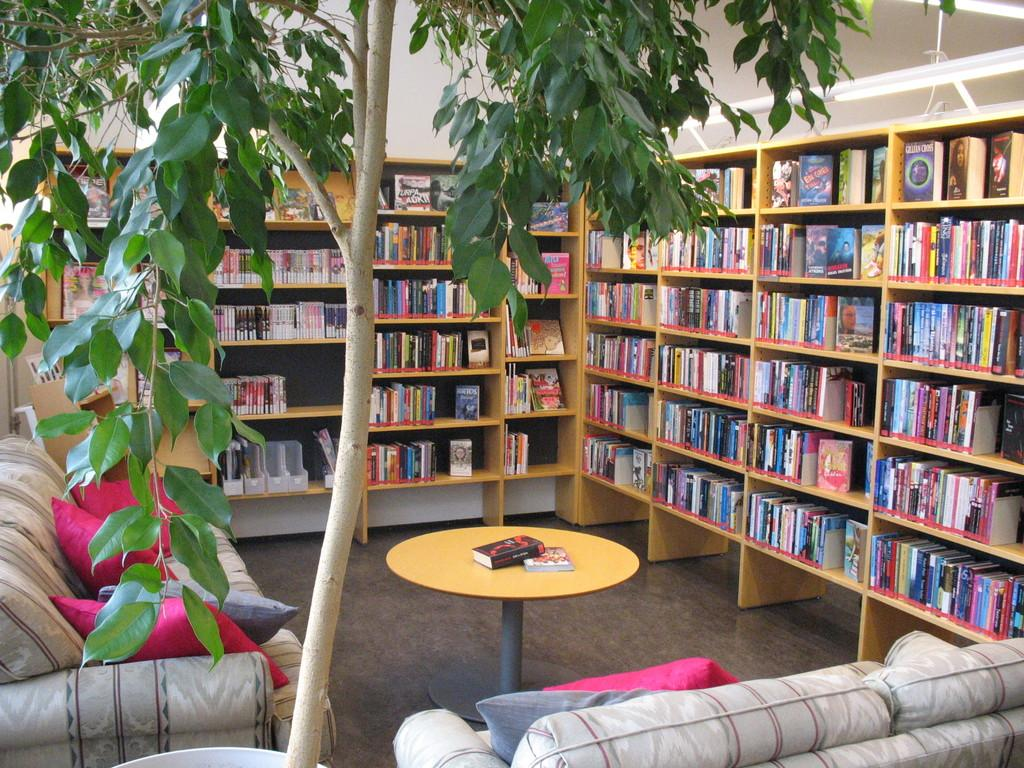What is on the floor in the image? There is a table on the floor in the image. What is on the table? There are books on the table. What other furniture can be seen in the image? There is a bookshelf and a sofa in the image. What is on the sofa? There are pillows on the sofa. What type of vegetation is present in the image? There is a tree in the image. What can be seen in the image that provides illumination? There are lights in the image. Can you tell me how many records are stacked on the bookshelf in the image? There is no record present in the image; only books, a table, a sofa, pillows, a tree, and lights are visible. Is there a comb visible on the sofa in the image? There is no comb present in the image; only pillows, a sofa, a table, books, a bookshelf, a tree, and lights are visible. 